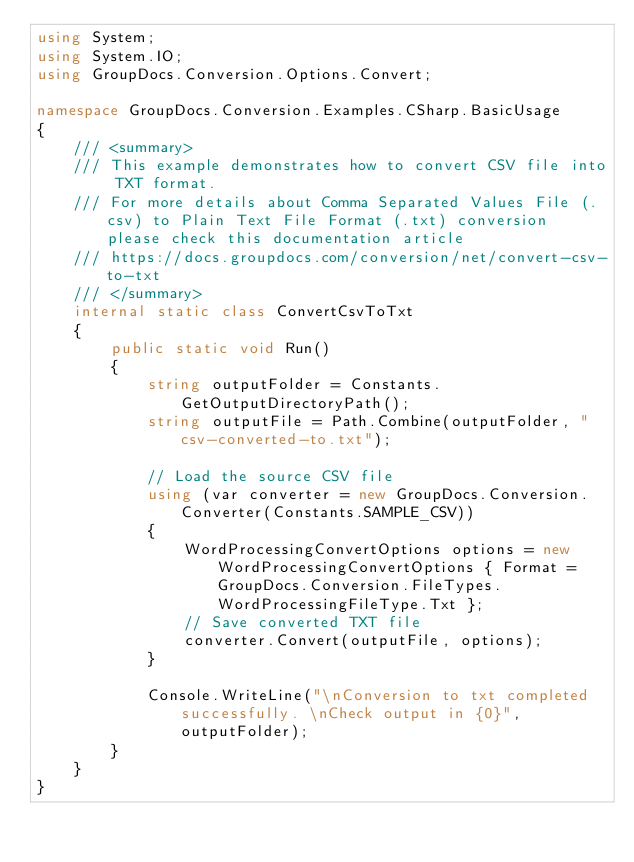Convert code to text. <code><loc_0><loc_0><loc_500><loc_500><_C#_>using System;
using System.IO;
using GroupDocs.Conversion.Options.Convert;

namespace GroupDocs.Conversion.Examples.CSharp.BasicUsage
{
    /// <summary>
    /// This example demonstrates how to convert CSV file into TXT format.
    /// For more details about Comma Separated Values File (.csv) to Plain Text File Format (.txt) conversion please check this documentation article 
    /// https://docs.groupdocs.com/conversion/net/convert-csv-to-txt
    /// </summary>
    internal static class ConvertCsvToTxt
    {
        public static void Run()
        {
            string outputFolder = Constants.GetOutputDirectoryPath();
            string outputFile = Path.Combine(outputFolder, "csv-converted-to.txt");
            
            // Load the source CSV file
            using (var converter = new GroupDocs.Conversion.Converter(Constants.SAMPLE_CSV))
            {
                WordProcessingConvertOptions options = new WordProcessingConvertOptions { Format = GroupDocs.Conversion.FileTypes.WordProcessingFileType.Txt };
                // Save converted TXT file
                converter.Convert(outputFile, options);
            }

            Console.WriteLine("\nConversion to txt completed successfully. \nCheck output in {0}", outputFolder);
        }
    }
}
</code> 